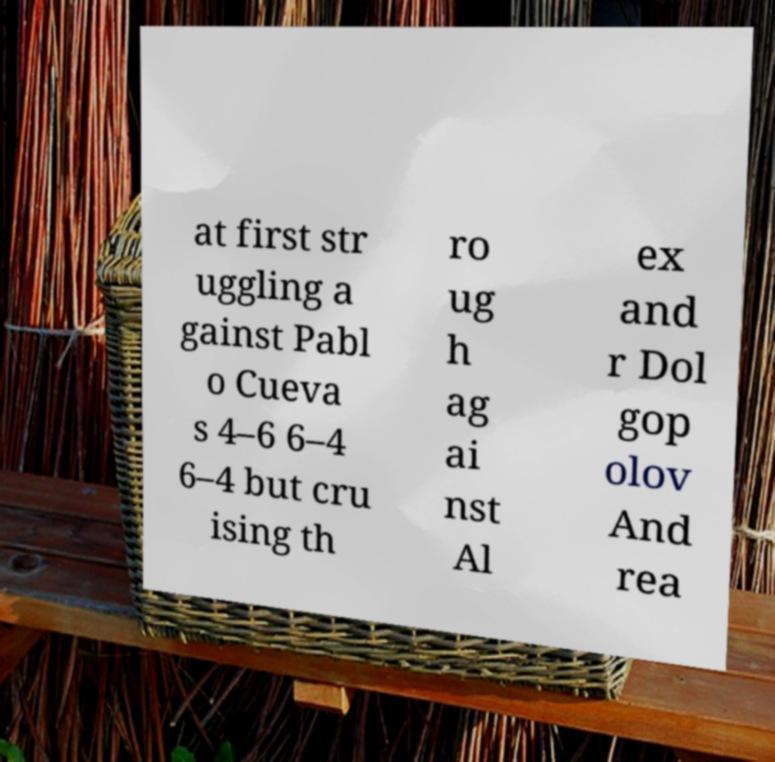What messages or text are displayed in this image? I need them in a readable, typed format. at first str uggling a gainst Pabl o Cueva s 4–6 6–4 6–4 but cru ising th ro ug h ag ai nst Al ex and r Dol gop olov And rea 